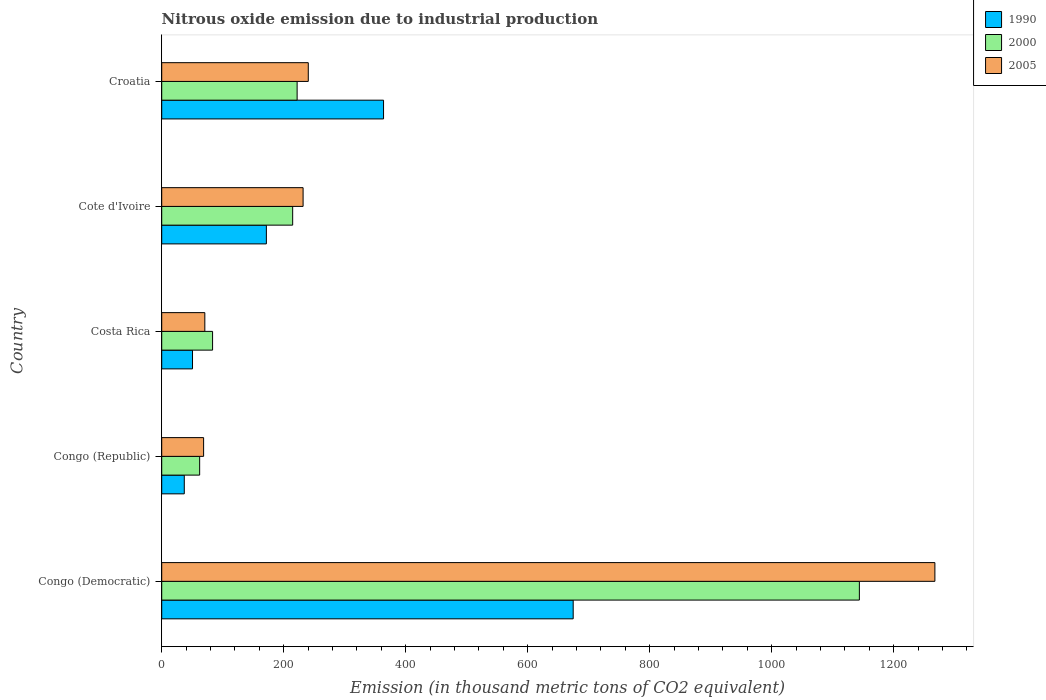How many different coloured bars are there?
Offer a very short reply. 3. Are the number of bars on each tick of the Y-axis equal?
Your response must be concise. Yes. How many bars are there on the 2nd tick from the top?
Provide a short and direct response. 3. How many bars are there on the 2nd tick from the bottom?
Make the answer very short. 3. What is the label of the 5th group of bars from the top?
Give a very brief answer. Congo (Democratic). What is the amount of nitrous oxide emitted in 2005 in Croatia?
Your answer should be compact. 240.3. Across all countries, what is the maximum amount of nitrous oxide emitted in 1990?
Make the answer very short. 674.6. In which country was the amount of nitrous oxide emitted in 2005 maximum?
Your answer should be very brief. Congo (Democratic). In which country was the amount of nitrous oxide emitted in 2000 minimum?
Offer a very short reply. Congo (Republic). What is the total amount of nitrous oxide emitted in 1990 in the graph?
Your answer should be very brief. 1297.4. What is the difference between the amount of nitrous oxide emitted in 2005 in Costa Rica and the amount of nitrous oxide emitted in 1990 in Congo (Democratic)?
Keep it short and to the point. -603.9. What is the average amount of nitrous oxide emitted in 2005 per country?
Your answer should be very brief. 375.82. What is the difference between the amount of nitrous oxide emitted in 1990 and amount of nitrous oxide emitted in 2005 in Costa Rica?
Provide a short and direct response. -20.2. What is the ratio of the amount of nitrous oxide emitted in 2005 in Congo (Democratic) to that in Costa Rica?
Your answer should be compact. 17.93. Is the amount of nitrous oxide emitted in 2000 in Costa Rica less than that in Croatia?
Provide a succinct answer. Yes. What is the difference between the highest and the second highest amount of nitrous oxide emitted in 2005?
Make the answer very short. 1027.3. What is the difference between the highest and the lowest amount of nitrous oxide emitted in 2005?
Offer a terse response. 1198.9. Is the sum of the amount of nitrous oxide emitted in 2005 in Costa Rica and Cote d'Ivoire greater than the maximum amount of nitrous oxide emitted in 1990 across all countries?
Your response must be concise. No. How many bars are there?
Provide a succinct answer. 15. How many countries are there in the graph?
Offer a very short reply. 5. What is the difference between two consecutive major ticks on the X-axis?
Your answer should be compact. 200. Are the values on the major ticks of X-axis written in scientific E-notation?
Ensure brevity in your answer.  No. Does the graph contain any zero values?
Your answer should be compact. No. Where does the legend appear in the graph?
Your answer should be compact. Top right. How are the legend labels stacked?
Your answer should be very brief. Vertical. What is the title of the graph?
Offer a terse response. Nitrous oxide emission due to industrial production. What is the label or title of the X-axis?
Keep it short and to the point. Emission (in thousand metric tons of CO2 equivalent). What is the Emission (in thousand metric tons of CO2 equivalent) of 1990 in Congo (Democratic)?
Your answer should be compact. 674.6. What is the Emission (in thousand metric tons of CO2 equivalent) of 2000 in Congo (Democratic)?
Offer a terse response. 1143.8. What is the Emission (in thousand metric tons of CO2 equivalent) of 2005 in Congo (Democratic)?
Offer a terse response. 1267.6. What is the Emission (in thousand metric tons of CO2 equivalent) of 2000 in Congo (Republic)?
Ensure brevity in your answer.  62.2. What is the Emission (in thousand metric tons of CO2 equivalent) of 2005 in Congo (Republic)?
Your answer should be very brief. 68.7. What is the Emission (in thousand metric tons of CO2 equivalent) in 1990 in Costa Rica?
Provide a succinct answer. 50.5. What is the Emission (in thousand metric tons of CO2 equivalent) in 2000 in Costa Rica?
Ensure brevity in your answer.  83.4. What is the Emission (in thousand metric tons of CO2 equivalent) in 2005 in Costa Rica?
Ensure brevity in your answer.  70.7. What is the Emission (in thousand metric tons of CO2 equivalent) in 1990 in Cote d'Ivoire?
Your answer should be compact. 171.6. What is the Emission (in thousand metric tons of CO2 equivalent) in 2000 in Cote d'Ivoire?
Your response must be concise. 214.7. What is the Emission (in thousand metric tons of CO2 equivalent) of 2005 in Cote d'Ivoire?
Make the answer very short. 231.8. What is the Emission (in thousand metric tons of CO2 equivalent) in 1990 in Croatia?
Offer a terse response. 363.7. What is the Emission (in thousand metric tons of CO2 equivalent) of 2000 in Croatia?
Offer a terse response. 222. What is the Emission (in thousand metric tons of CO2 equivalent) in 2005 in Croatia?
Provide a succinct answer. 240.3. Across all countries, what is the maximum Emission (in thousand metric tons of CO2 equivalent) of 1990?
Keep it short and to the point. 674.6. Across all countries, what is the maximum Emission (in thousand metric tons of CO2 equivalent) in 2000?
Give a very brief answer. 1143.8. Across all countries, what is the maximum Emission (in thousand metric tons of CO2 equivalent) in 2005?
Your answer should be compact. 1267.6. Across all countries, what is the minimum Emission (in thousand metric tons of CO2 equivalent) in 2000?
Your answer should be compact. 62.2. Across all countries, what is the minimum Emission (in thousand metric tons of CO2 equivalent) in 2005?
Provide a succinct answer. 68.7. What is the total Emission (in thousand metric tons of CO2 equivalent) in 1990 in the graph?
Provide a succinct answer. 1297.4. What is the total Emission (in thousand metric tons of CO2 equivalent) in 2000 in the graph?
Make the answer very short. 1726.1. What is the total Emission (in thousand metric tons of CO2 equivalent) of 2005 in the graph?
Keep it short and to the point. 1879.1. What is the difference between the Emission (in thousand metric tons of CO2 equivalent) in 1990 in Congo (Democratic) and that in Congo (Republic)?
Offer a terse response. 637.6. What is the difference between the Emission (in thousand metric tons of CO2 equivalent) of 2000 in Congo (Democratic) and that in Congo (Republic)?
Give a very brief answer. 1081.6. What is the difference between the Emission (in thousand metric tons of CO2 equivalent) in 2005 in Congo (Democratic) and that in Congo (Republic)?
Make the answer very short. 1198.9. What is the difference between the Emission (in thousand metric tons of CO2 equivalent) of 1990 in Congo (Democratic) and that in Costa Rica?
Offer a very short reply. 624.1. What is the difference between the Emission (in thousand metric tons of CO2 equivalent) in 2000 in Congo (Democratic) and that in Costa Rica?
Keep it short and to the point. 1060.4. What is the difference between the Emission (in thousand metric tons of CO2 equivalent) in 2005 in Congo (Democratic) and that in Costa Rica?
Keep it short and to the point. 1196.9. What is the difference between the Emission (in thousand metric tons of CO2 equivalent) of 1990 in Congo (Democratic) and that in Cote d'Ivoire?
Your answer should be very brief. 503. What is the difference between the Emission (in thousand metric tons of CO2 equivalent) in 2000 in Congo (Democratic) and that in Cote d'Ivoire?
Keep it short and to the point. 929.1. What is the difference between the Emission (in thousand metric tons of CO2 equivalent) of 2005 in Congo (Democratic) and that in Cote d'Ivoire?
Your response must be concise. 1035.8. What is the difference between the Emission (in thousand metric tons of CO2 equivalent) of 1990 in Congo (Democratic) and that in Croatia?
Give a very brief answer. 310.9. What is the difference between the Emission (in thousand metric tons of CO2 equivalent) of 2000 in Congo (Democratic) and that in Croatia?
Provide a succinct answer. 921.8. What is the difference between the Emission (in thousand metric tons of CO2 equivalent) of 2005 in Congo (Democratic) and that in Croatia?
Keep it short and to the point. 1027.3. What is the difference between the Emission (in thousand metric tons of CO2 equivalent) of 1990 in Congo (Republic) and that in Costa Rica?
Make the answer very short. -13.5. What is the difference between the Emission (in thousand metric tons of CO2 equivalent) of 2000 in Congo (Republic) and that in Costa Rica?
Offer a very short reply. -21.2. What is the difference between the Emission (in thousand metric tons of CO2 equivalent) of 2005 in Congo (Republic) and that in Costa Rica?
Offer a terse response. -2. What is the difference between the Emission (in thousand metric tons of CO2 equivalent) in 1990 in Congo (Republic) and that in Cote d'Ivoire?
Offer a very short reply. -134.6. What is the difference between the Emission (in thousand metric tons of CO2 equivalent) of 2000 in Congo (Republic) and that in Cote d'Ivoire?
Make the answer very short. -152.5. What is the difference between the Emission (in thousand metric tons of CO2 equivalent) of 2005 in Congo (Republic) and that in Cote d'Ivoire?
Give a very brief answer. -163.1. What is the difference between the Emission (in thousand metric tons of CO2 equivalent) of 1990 in Congo (Republic) and that in Croatia?
Your answer should be compact. -326.7. What is the difference between the Emission (in thousand metric tons of CO2 equivalent) in 2000 in Congo (Republic) and that in Croatia?
Offer a very short reply. -159.8. What is the difference between the Emission (in thousand metric tons of CO2 equivalent) of 2005 in Congo (Republic) and that in Croatia?
Offer a very short reply. -171.6. What is the difference between the Emission (in thousand metric tons of CO2 equivalent) in 1990 in Costa Rica and that in Cote d'Ivoire?
Provide a short and direct response. -121.1. What is the difference between the Emission (in thousand metric tons of CO2 equivalent) of 2000 in Costa Rica and that in Cote d'Ivoire?
Offer a terse response. -131.3. What is the difference between the Emission (in thousand metric tons of CO2 equivalent) of 2005 in Costa Rica and that in Cote d'Ivoire?
Provide a succinct answer. -161.1. What is the difference between the Emission (in thousand metric tons of CO2 equivalent) of 1990 in Costa Rica and that in Croatia?
Give a very brief answer. -313.2. What is the difference between the Emission (in thousand metric tons of CO2 equivalent) of 2000 in Costa Rica and that in Croatia?
Your answer should be very brief. -138.6. What is the difference between the Emission (in thousand metric tons of CO2 equivalent) in 2005 in Costa Rica and that in Croatia?
Give a very brief answer. -169.6. What is the difference between the Emission (in thousand metric tons of CO2 equivalent) of 1990 in Cote d'Ivoire and that in Croatia?
Give a very brief answer. -192.1. What is the difference between the Emission (in thousand metric tons of CO2 equivalent) of 2000 in Cote d'Ivoire and that in Croatia?
Provide a succinct answer. -7.3. What is the difference between the Emission (in thousand metric tons of CO2 equivalent) in 1990 in Congo (Democratic) and the Emission (in thousand metric tons of CO2 equivalent) in 2000 in Congo (Republic)?
Your answer should be compact. 612.4. What is the difference between the Emission (in thousand metric tons of CO2 equivalent) in 1990 in Congo (Democratic) and the Emission (in thousand metric tons of CO2 equivalent) in 2005 in Congo (Republic)?
Your answer should be very brief. 605.9. What is the difference between the Emission (in thousand metric tons of CO2 equivalent) of 2000 in Congo (Democratic) and the Emission (in thousand metric tons of CO2 equivalent) of 2005 in Congo (Republic)?
Ensure brevity in your answer.  1075.1. What is the difference between the Emission (in thousand metric tons of CO2 equivalent) in 1990 in Congo (Democratic) and the Emission (in thousand metric tons of CO2 equivalent) in 2000 in Costa Rica?
Provide a succinct answer. 591.2. What is the difference between the Emission (in thousand metric tons of CO2 equivalent) of 1990 in Congo (Democratic) and the Emission (in thousand metric tons of CO2 equivalent) of 2005 in Costa Rica?
Make the answer very short. 603.9. What is the difference between the Emission (in thousand metric tons of CO2 equivalent) of 2000 in Congo (Democratic) and the Emission (in thousand metric tons of CO2 equivalent) of 2005 in Costa Rica?
Ensure brevity in your answer.  1073.1. What is the difference between the Emission (in thousand metric tons of CO2 equivalent) of 1990 in Congo (Democratic) and the Emission (in thousand metric tons of CO2 equivalent) of 2000 in Cote d'Ivoire?
Give a very brief answer. 459.9. What is the difference between the Emission (in thousand metric tons of CO2 equivalent) in 1990 in Congo (Democratic) and the Emission (in thousand metric tons of CO2 equivalent) in 2005 in Cote d'Ivoire?
Your answer should be very brief. 442.8. What is the difference between the Emission (in thousand metric tons of CO2 equivalent) in 2000 in Congo (Democratic) and the Emission (in thousand metric tons of CO2 equivalent) in 2005 in Cote d'Ivoire?
Provide a short and direct response. 912. What is the difference between the Emission (in thousand metric tons of CO2 equivalent) of 1990 in Congo (Democratic) and the Emission (in thousand metric tons of CO2 equivalent) of 2000 in Croatia?
Your answer should be compact. 452.6. What is the difference between the Emission (in thousand metric tons of CO2 equivalent) in 1990 in Congo (Democratic) and the Emission (in thousand metric tons of CO2 equivalent) in 2005 in Croatia?
Your answer should be compact. 434.3. What is the difference between the Emission (in thousand metric tons of CO2 equivalent) in 2000 in Congo (Democratic) and the Emission (in thousand metric tons of CO2 equivalent) in 2005 in Croatia?
Your answer should be compact. 903.5. What is the difference between the Emission (in thousand metric tons of CO2 equivalent) in 1990 in Congo (Republic) and the Emission (in thousand metric tons of CO2 equivalent) in 2000 in Costa Rica?
Your answer should be very brief. -46.4. What is the difference between the Emission (in thousand metric tons of CO2 equivalent) in 1990 in Congo (Republic) and the Emission (in thousand metric tons of CO2 equivalent) in 2005 in Costa Rica?
Provide a short and direct response. -33.7. What is the difference between the Emission (in thousand metric tons of CO2 equivalent) of 2000 in Congo (Republic) and the Emission (in thousand metric tons of CO2 equivalent) of 2005 in Costa Rica?
Your answer should be compact. -8.5. What is the difference between the Emission (in thousand metric tons of CO2 equivalent) in 1990 in Congo (Republic) and the Emission (in thousand metric tons of CO2 equivalent) in 2000 in Cote d'Ivoire?
Provide a short and direct response. -177.7. What is the difference between the Emission (in thousand metric tons of CO2 equivalent) in 1990 in Congo (Republic) and the Emission (in thousand metric tons of CO2 equivalent) in 2005 in Cote d'Ivoire?
Provide a short and direct response. -194.8. What is the difference between the Emission (in thousand metric tons of CO2 equivalent) of 2000 in Congo (Republic) and the Emission (in thousand metric tons of CO2 equivalent) of 2005 in Cote d'Ivoire?
Keep it short and to the point. -169.6. What is the difference between the Emission (in thousand metric tons of CO2 equivalent) of 1990 in Congo (Republic) and the Emission (in thousand metric tons of CO2 equivalent) of 2000 in Croatia?
Make the answer very short. -185. What is the difference between the Emission (in thousand metric tons of CO2 equivalent) of 1990 in Congo (Republic) and the Emission (in thousand metric tons of CO2 equivalent) of 2005 in Croatia?
Provide a short and direct response. -203.3. What is the difference between the Emission (in thousand metric tons of CO2 equivalent) in 2000 in Congo (Republic) and the Emission (in thousand metric tons of CO2 equivalent) in 2005 in Croatia?
Offer a terse response. -178.1. What is the difference between the Emission (in thousand metric tons of CO2 equivalent) of 1990 in Costa Rica and the Emission (in thousand metric tons of CO2 equivalent) of 2000 in Cote d'Ivoire?
Your answer should be compact. -164.2. What is the difference between the Emission (in thousand metric tons of CO2 equivalent) in 1990 in Costa Rica and the Emission (in thousand metric tons of CO2 equivalent) in 2005 in Cote d'Ivoire?
Provide a short and direct response. -181.3. What is the difference between the Emission (in thousand metric tons of CO2 equivalent) of 2000 in Costa Rica and the Emission (in thousand metric tons of CO2 equivalent) of 2005 in Cote d'Ivoire?
Give a very brief answer. -148.4. What is the difference between the Emission (in thousand metric tons of CO2 equivalent) in 1990 in Costa Rica and the Emission (in thousand metric tons of CO2 equivalent) in 2000 in Croatia?
Ensure brevity in your answer.  -171.5. What is the difference between the Emission (in thousand metric tons of CO2 equivalent) of 1990 in Costa Rica and the Emission (in thousand metric tons of CO2 equivalent) of 2005 in Croatia?
Make the answer very short. -189.8. What is the difference between the Emission (in thousand metric tons of CO2 equivalent) of 2000 in Costa Rica and the Emission (in thousand metric tons of CO2 equivalent) of 2005 in Croatia?
Your answer should be compact. -156.9. What is the difference between the Emission (in thousand metric tons of CO2 equivalent) in 1990 in Cote d'Ivoire and the Emission (in thousand metric tons of CO2 equivalent) in 2000 in Croatia?
Offer a terse response. -50.4. What is the difference between the Emission (in thousand metric tons of CO2 equivalent) in 1990 in Cote d'Ivoire and the Emission (in thousand metric tons of CO2 equivalent) in 2005 in Croatia?
Offer a very short reply. -68.7. What is the difference between the Emission (in thousand metric tons of CO2 equivalent) of 2000 in Cote d'Ivoire and the Emission (in thousand metric tons of CO2 equivalent) of 2005 in Croatia?
Provide a succinct answer. -25.6. What is the average Emission (in thousand metric tons of CO2 equivalent) in 1990 per country?
Your response must be concise. 259.48. What is the average Emission (in thousand metric tons of CO2 equivalent) in 2000 per country?
Your response must be concise. 345.22. What is the average Emission (in thousand metric tons of CO2 equivalent) in 2005 per country?
Ensure brevity in your answer.  375.82. What is the difference between the Emission (in thousand metric tons of CO2 equivalent) in 1990 and Emission (in thousand metric tons of CO2 equivalent) in 2000 in Congo (Democratic)?
Offer a terse response. -469.2. What is the difference between the Emission (in thousand metric tons of CO2 equivalent) of 1990 and Emission (in thousand metric tons of CO2 equivalent) of 2005 in Congo (Democratic)?
Provide a succinct answer. -593. What is the difference between the Emission (in thousand metric tons of CO2 equivalent) of 2000 and Emission (in thousand metric tons of CO2 equivalent) of 2005 in Congo (Democratic)?
Keep it short and to the point. -123.8. What is the difference between the Emission (in thousand metric tons of CO2 equivalent) of 1990 and Emission (in thousand metric tons of CO2 equivalent) of 2000 in Congo (Republic)?
Ensure brevity in your answer.  -25.2. What is the difference between the Emission (in thousand metric tons of CO2 equivalent) in 1990 and Emission (in thousand metric tons of CO2 equivalent) in 2005 in Congo (Republic)?
Your response must be concise. -31.7. What is the difference between the Emission (in thousand metric tons of CO2 equivalent) of 2000 and Emission (in thousand metric tons of CO2 equivalent) of 2005 in Congo (Republic)?
Make the answer very short. -6.5. What is the difference between the Emission (in thousand metric tons of CO2 equivalent) of 1990 and Emission (in thousand metric tons of CO2 equivalent) of 2000 in Costa Rica?
Keep it short and to the point. -32.9. What is the difference between the Emission (in thousand metric tons of CO2 equivalent) in 1990 and Emission (in thousand metric tons of CO2 equivalent) in 2005 in Costa Rica?
Offer a terse response. -20.2. What is the difference between the Emission (in thousand metric tons of CO2 equivalent) of 2000 and Emission (in thousand metric tons of CO2 equivalent) of 2005 in Costa Rica?
Provide a short and direct response. 12.7. What is the difference between the Emission (in thousand metric tons of CO2 equivalent) in 1990 and Emission (in thousand metric tons of CO2 equivalent) in 2000 in Cote d'Ivoire?
Provide a succinct answer. -43.1. What is the difference between the Emission (in thousand metric tons of CO2 equivalent) in 1990 and Emission (in thousand metric tons of CO2 equivalent) in 2005 in Cote d'Ivoire?
Your answer should be very brief. -60.2. What is the difference between the Emission (in thousand metric tons of CO2 equivalent) of 2000 and Emission (in thousand metric tons of CO2 equivalent) of 2005 in Cote d'Ivoire?
Keep it short and to the point. -17.1. What is the difference between the Emission (in thousand metric tons of CO2 equivalent) in 1990 and Emission (in thousand metric tons of CO2 equivalent) in 2000 in Croatia?
Offer a terse response. 141.7. What is the difference between the Emission (in thousand metric tons of CO2 equivalent) of 1990 and Emission (in thousand metric tons of CO2 equivalent) of 2005 in Croatia?
Your response must be concise. 123.4. What is the difference between the Emission (in thousand metric tons of CO2 equivalent) of 2000 and Emission (in thousand metric tons of CO2 equivalent) of 2005 in Croatia?
Provide a succinct answer. -18.3. What is the ratio of the Emission (in thousand metric tons of CO2 equivalent) of 1990 in Congo (Democratic) to that in Congo (Republic)?
Your answer should be very brief. 18.23. What is the ratio of the Emission (in thousand metric tons of CO2 equivalent) of 2000 in Congo (Democratic) to that in Congo (Republic)?
Your response must be concise. 18.39. What is the ratio of the Emission (in thousand metric tons of CO2 equivalent) in 2005 in Congo (Democratic) to that in Congo (Republic)?
Ensure brevity in your answer.  18.45. What is the ratio of the Emission (in thousand metric tons of CO2 equivalent) of 1990 in Congo (Democratic) to that in Costa Rica?
Offer a very short reply. 13.36. What is the ratio of the Emission (in thousand metric tons of CO2 equivalent) of 2000 in Congo (Democratic) to that in Costa Rica?
Your answer should be very brief. 13.71. What is the ratio of the Emission (in thousand metric tons of CO2 equivalent) of 2005 in Congo (Democratic) to that in Costa Rica?
Your answer should be compact. 17.93. What is the ratio of the Emission (in thousand metric tons of CO2 equivalent) in 1990 in Congo (Democratic) to that in Cote d'Ivoire?
Your response must be concise. 3.93. What is the ratio of the Emission (in thousand metric tons of CO2 equivalent) in 2000 in Congo (Democratic) to that in Cote d'Ivoire?
Offer a very short reply. 5.33. What is the ratio of the Emission (in thousand metric tons of CO2 equivalent) of 2005 in Congo (Democratic) to that in Cote d'Ivoire?
Provide a succinct answer. 5.47. What is the ratio of the Emission (in thousand metric tons of CO2 equivalent) in 1990 in Congo (Democratic) to that in Croatia?
Give a very brief answer. 1.85. What is the ratio of the Emission (in thousand metric tons of CO2 equivalent) of 2000 in Congo (Democratic) to that in Croatia?
Offer a very short reply. 5.15. What is the ratio of the Emission (in thousand metric tons of CO2 equivalent) of 2005 in Congo (Democratic) to that in Croatia?
Your answer should be very brief. 5.28. What is the ratio of the Emission (in thousand metric tons of CO2 equivalent) in 1990 in Congo (Republic) to that in Costa Rica?
Your answer should be very brief. 0.73. What is the ratio of the Emission (in thousand metric tons of CO2 equivalent) in 2000 in Congo (Republic) to that in Costa Rica?
Offer a very short reply. 0.75. What is the ratio of the Emission (in thousand metric tons of CO2 equivalent) of 2005 in Congo (Republic) to that in Costa Rica?
Your response must be concise. 0.97. What is the ratio of the Emission (in thousand metric tons of CO2 equivalent) of 1990 in Congo (Republic) to that in Cote d'Ivoire?
Give a very brief answer. 0.22. What is the ratio of the Emission (in thousand metric tons of CO2 equivalent) in 2000 in Congo (Republic) to that in Cote d'Ivoire?
Your response must be concise. 0.29. What is the ratio of the Emission (in thousand metric tons of CO2 equivalent) of 2005 in Congo (Republic) to that in Cote d'Ivoire?
Your answer should be very brief. 0.3. What is the ratio of the Emission (in thousand metric tons of CO2 equivalent) of 1990 in Congo (Republic) to that in Croatia?
Ensure brevity in your answer.  0.1. What is the ratio of the Emission (in thousand metric tons of CO2 equivalent) in 2000 in Congo (Republic) to that in Croatia?
Make the answer very short. 0.28. What is the ratio of the Emission (in thousand metric tons of CO2 equivalent) of 2005 in Congo (Republic) to that in Croatia?
Your answer should be very brief. 0.29. What is the ratio of the Emission (in thousand metric tons of CO2 equivalent) of 1990 in Costa Rica to that in Cote d'Ivoire?
Give a very brief answer. 0.29. What is the ratio of the Emission (in thousand metric tons of CO2 equivalent) in 2000 in Costa Rica to that in Cote d'Ivoire?
Make the answer very short. 0.39. What is the ratio of the Emission (in thousand metric tons of CO2 equivalent) in 2005 in Costa Rica to that in Cote d'Ivoire?
Your answer should be very brief. 0.3. What is the ratio of the Emission (in thousand metric tons of CO2 equivalent) of 1990 in Costa Rica to that in Croatia?
Offer a terse response. 0.14. What is the ratio of the Emission (in thousand metric tons of CO2 equivalent) of 2000 in Costa Rica to that in Croatia?
Your answer should be very brief. 0.38. What is the ratio of the Emission (in thousand metric tons of CO2 equivalent) of 2005 in Costa Rica to that in Croatia?
Your answer should be very brief. 0.29. What is the ratio of the Emission (in thousand metric tons of CO2 equivalent) in 1990 in Cote d'Ivoire to that in Croatia?
Provide a succinct answer. 0.47. What is the ratio of the Emission (in thousand metric tons of CO2 equivalent) in 2000 in Cote d'Ivoire to that in Croatia?
Keep it short and to the point. 0.97. What is the ratio of the Emission (in thousand metric tons of CO2 equivalent) of 2005 in Cote d'Ivoire to that in Croatia?
Offer a very short reply. 0.96. What is the difference between the highest and the second highest Emission (in thousand metric tons of CO2 equivalent) in 1990?
Provide a succinct answer. 310.9. What is the difference between the highest and the second highest Emission (in thousand metric tons of CO2 equivalent) of 2000?
Your answer should be compact. 921.8. What is the difference between the highest and the second highest Emission (in thousand metric tons of CO2 equivalent) of 2005?
Your answer should be compact. 1027.3. What is the difference between the highest and the lowest Emission (in thousand metric tons of CO2 equivalent) in 1990?
Ensure brevity in your answer.  637.6. What is the difference between the highest and the lowest Emission (in thousand metric tons of CO2 equivalent) in 2000?
Your response must be concise. 1081.6. What is the difference between the highest and the lowest Emission (in thousand metric tons of CO2 equivalent) in 2005?
Your answer should be very brief. 1198.9. 